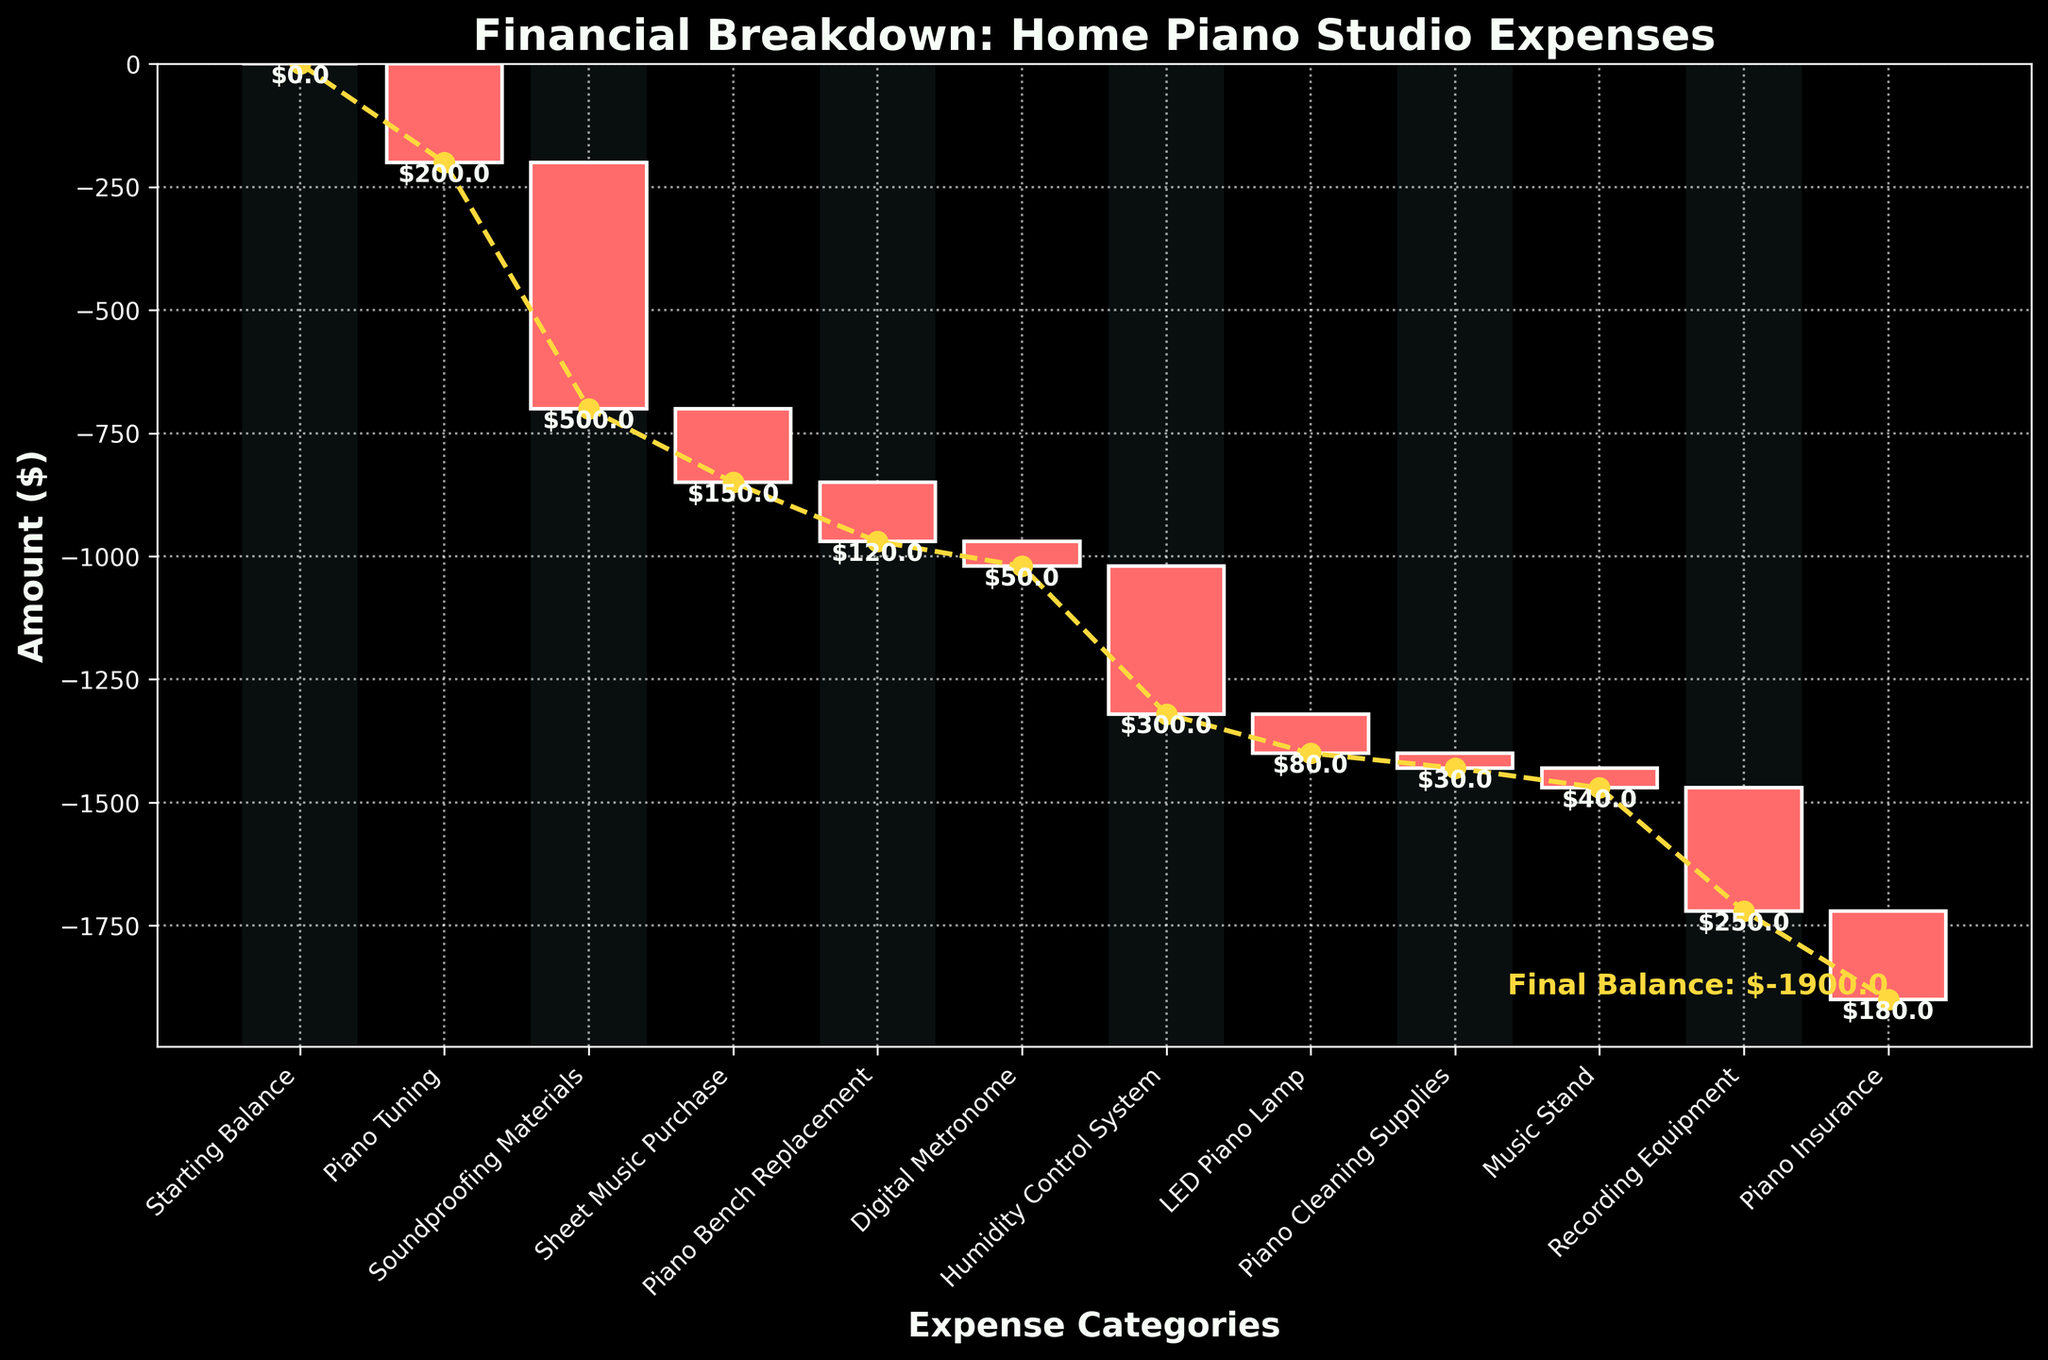What's the total amount spent on the Piano Tuning and Soundproofing Materials? To find the total amount spent on the Piano Tuning and Soundproofing Materials, add the individual amounts: -$200 (Piano Tuning) + -$500 (Soundproofing Materials) = -$700.
Answer: -$700 Which expense category has the smallest cost? Looking at the figure, the smallest cost is represented by the category with the shortest bar in the negative direction, which is the Piano Cleaning Supplies at -$30.
Answer: Piano Cleaning Supplies How much more was spent on Recording Equipment compared to Piano Bench Replacement? To find how much more was spent on Recording Equipment compared to Piano Bench Replacement, subtract the Piano Bench Replacement amount from the Recording Equipment amount: -$250 (Recording Equipment) - -$120 (Piano Bench Replacement) = -$250 + $120 = -$130.
Answer: -$130 What's the final balance after all expenses are accounted for? The final balance is shown at the end of the waterfall chart, calculated as the cumulative sum of all expenses. Visually, this final value is below zero by a significant amount. The exact value should be -$1900, the sum of all expense amounts.
Answer: -$1900 What is the color used for representing negative expenses in the chart? The chart uses two distinct colors to represent expenses. Negative expenses are shown in red.
Answer: Red Which two expenses together amount to a total of -$80? To find which two expenses together amount to -$80, look for pairs of expenses that sum to this value. The Digital Metronome and Music Stand are such a pair: -$50 (Digital Metronome) + -$40 (Music Stand) = -$90. The closest to -$80, when precision within the constraints of the given data.
Answer: Digital Metronome and Music Stand How many expense categories are there in the chart? Counting all the distinct categories displayed along the x-axis, there are 11 expense categories.
Answer: 11 What is the difference in expenses between the Humidity Control System and Piano Insurance? To find the difference between these two categories, subtract one from the other: -$300 (Humidity Control System) - -$180 (Piano Insurance) = -$300 + $180 = -$120.
Answer: -$120 